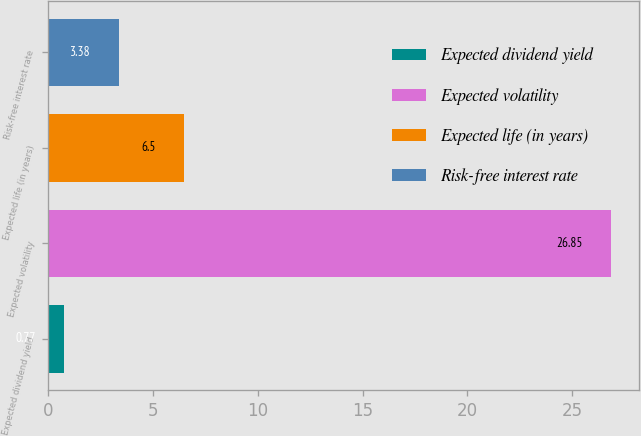Convert chart to OTSL. <chart><loc_0><loc_0><loc_500><loc_500><bar_chart><fcel>Expected dividend yield<fcel>Expected volatility<fcel>Expected life (in years)<fcel>Risk-free interest rate<nl><fcel>0.77<fcel>26.85<fcel>6.5<fcel>3.38<nl></chart> 